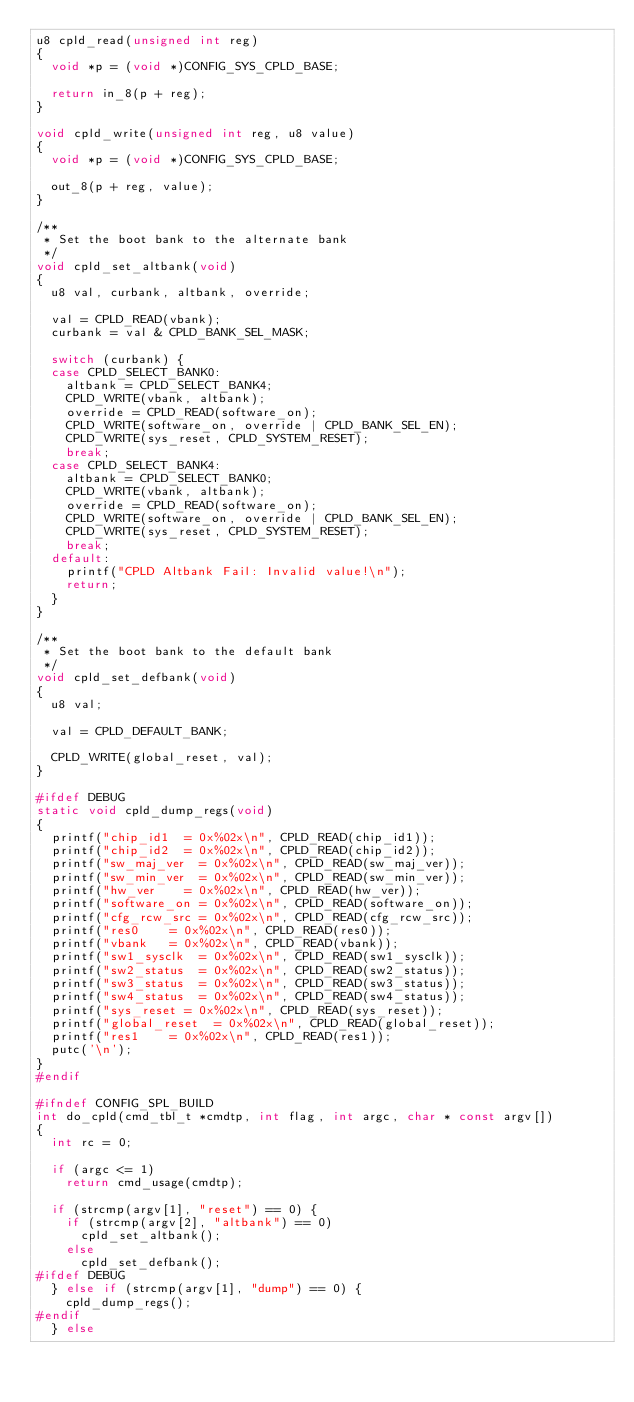<code> <loc_0><loc_0><loc_500><loc_500><_C_>u8 cpld_read(unsigned int reg)
{
	void *p = (void *)CONFIG_SYS_CPLD_BASE;

	return in_8(p + reg);
}

void cpld_write(unsigned int reg, u8 value)
{
	void *p = (void *)CONFIG_SYS_CPLD_BASE;

	out_8(p + reg, value);
}

/**
 * Set the boot bank to the alternate bank
 */
void cpld_set_altbank(void)
{
	u8 val, curbank, altbank, override;

	val = CPLD_READ(vbank);
	curbank = val & CPLD_BANK_SEL_MASK;

	switch (curbank) {
	case CPLD_SELECT_BANK0:
		altbank = CPLD_SELECT_BANK4;
		CPLD_WRITE(vbank, altbank);
		override = CPLD_READ(software_on);
		CPLD_WRITE(software_on, override | CPLD_BANK_SEL_EN);
		CPLD_WRITE(sys_reset, CPLD_SYSTEM_RESET);
		break;
	case CPLD_SELECT_BANK4:
		altbank = CPLD_SELECT_BANK0;
		CPLD_WRITE(vbank, altbank);
		override = CPLD_READ(software_on);
		CPLD_WRITE(software_on, override | CPLD_BANK_SEL_EN);
		CPLD_WRITE(sys_reset, CPLD_SYSTEM_RESET);
		break;
	default:
		printf("CPLD Altbank Fail: Invalid value!\n");
		return;
	}
}

/**
 * Set the boot bank to the default bank
 */
void cpld_set_defbank(void)
{
	u8 val;

	val = CPLD_DEFAULT_BANK;

	CPLD_WRITE(global_reset, val);
}

#ifdef DEBUG
static void cpld_dump_regs(void)
{
	printf("chip_id1	= 0x%02x\n", CPLD_READ(chip_id1));
	printf("chip_id2	= 0x%02x\n", CPLD_READ(chip_id2));
	printf("sw_maj_ver	= 0x%02x\n", CPLD_READ(sw_maj_ver));
	printf("sw_min_ver	= 0x%02x\n", CPLD_READ(sw_min_ver));
	printf("hw_ver		= 0x%02x\n", CPLD_READ(hw_ver));
	printf("software_on	= 0x%02x\n", CPLD_READ(software_on));
	printf("cfg_rcw_src	= 0x%02x\n", CPLD_READ(cfg_rcw_src));
	printf("res0		= 0x%02x\n", CPLD_READ(res0));
	printf("vbank		= 0x%02x\n", CPLD_READ(vbank));
	printf("sw1_sysclk	= 0x%02x\n", CPLD_READ(sw1_sysclk));
	printf("sw2_status	= 0x%02x\n", CPLD_READ(sw2_status));
	printf("sw3_status	= 0x%02x\n", CPLD_READ(sw3_status));
	printf("sw4_status	= 0x%02x\n", CPLD_READ(sw4_status));
	printf("sys_reset	= 0x%02x\n", CPLD_READ(sys_reset));
	printf("global_reset	= 0x%02x\n", CPLD_READ(global_reset));
	printf("res1		= 0x%02x\n", CPLD_READ(res1));
	putc('\n');
}
#endif

#ifndef CONFIG_SPL_BUILD
int do_cpld(cmd_tbl_t *cmdtp, int flag, int argc, char * const argv[])
{
	int rc = 0;

	if (argc <= 1)
		return cmd_usage(cmdtp);

	if (strcmp(argv[1], "reset") == 0) {
		if (strcmp(argv[2], "altbank") == 0)
			cpld_set_altbank();
		else
			cpld_set_defbank();
#ifdef DEBUG
	} else if (strcmp(argv[1], "dump") == 0) {
		cpld_dump_regs();
#endif
	} else</code> 